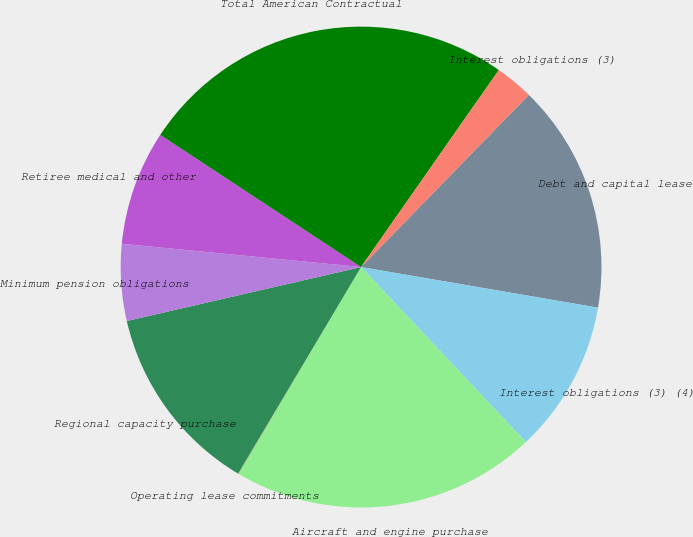Convert chart. <chart><loc_0><loc_0><loc_500><loc_500><pie_chart><fcel>Debt and capital lease<fcel>Interest obligations (3) (4)<fcel>Aircraft and engine purchase<fcel>Operating lease commitments<fcel>Regional capacity purchase<fcel>Minimum pension obligations<fcel>Retiree medical and other<fcel>Total American Contractual<fcel>Interest obligations (3)<nl><fcel>15.41%<fcel>10.28%<fcel>20.55%<fcel>0.02%<fcel>12.85%<fcel>5.15%<fcel>7.72%<fcel>25.45%<fcel>2.58%<nl></chart> 